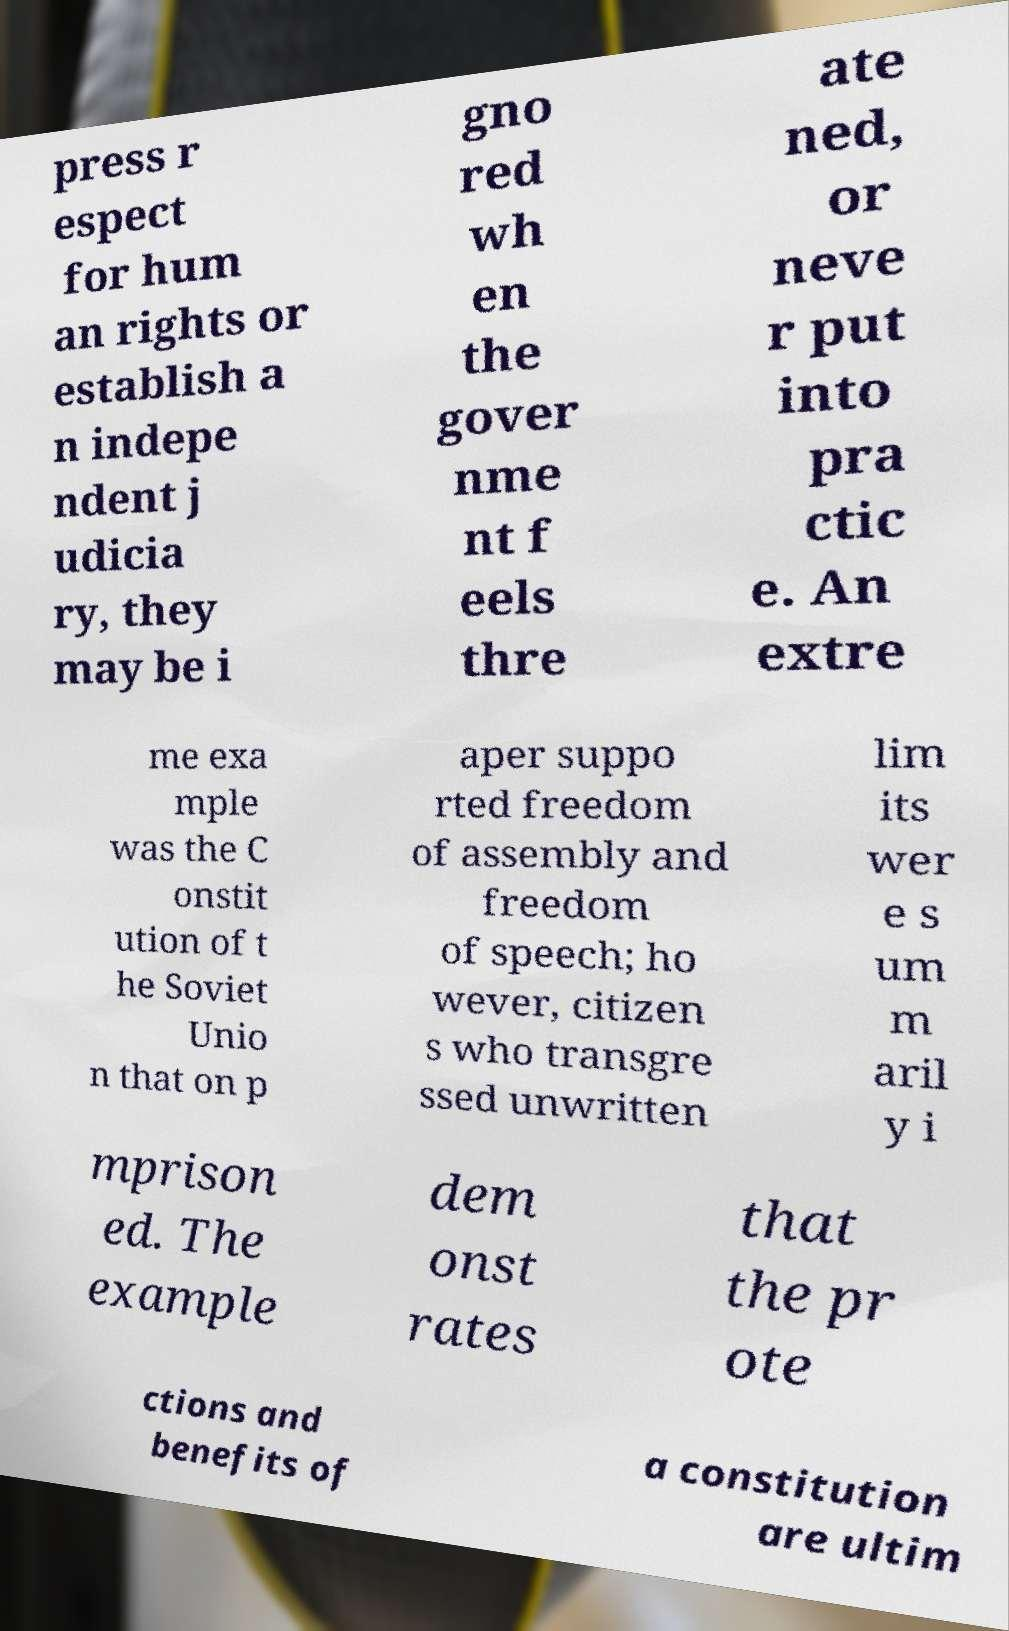For documentation purposes, I need the text within this image transcribed. Could you provide that? press r espect for hum an rights or establish a n indepe ndent j udicia ry, they may be i gno red wh en the gover nme nt f eels thre ate ned, or neve r put into pra ctic e. An extre me exa mple was the C onstit ution of t he Soviet Unio n that on p aper suppo rted freedom of assembly and freedom of speech; ho wever, citizen s who transgre ssed unwritten lim its wer e s um m aril y i mprison ed. The example dem onst rates that the pr ote ctions and benefits of a constitution are ultim 